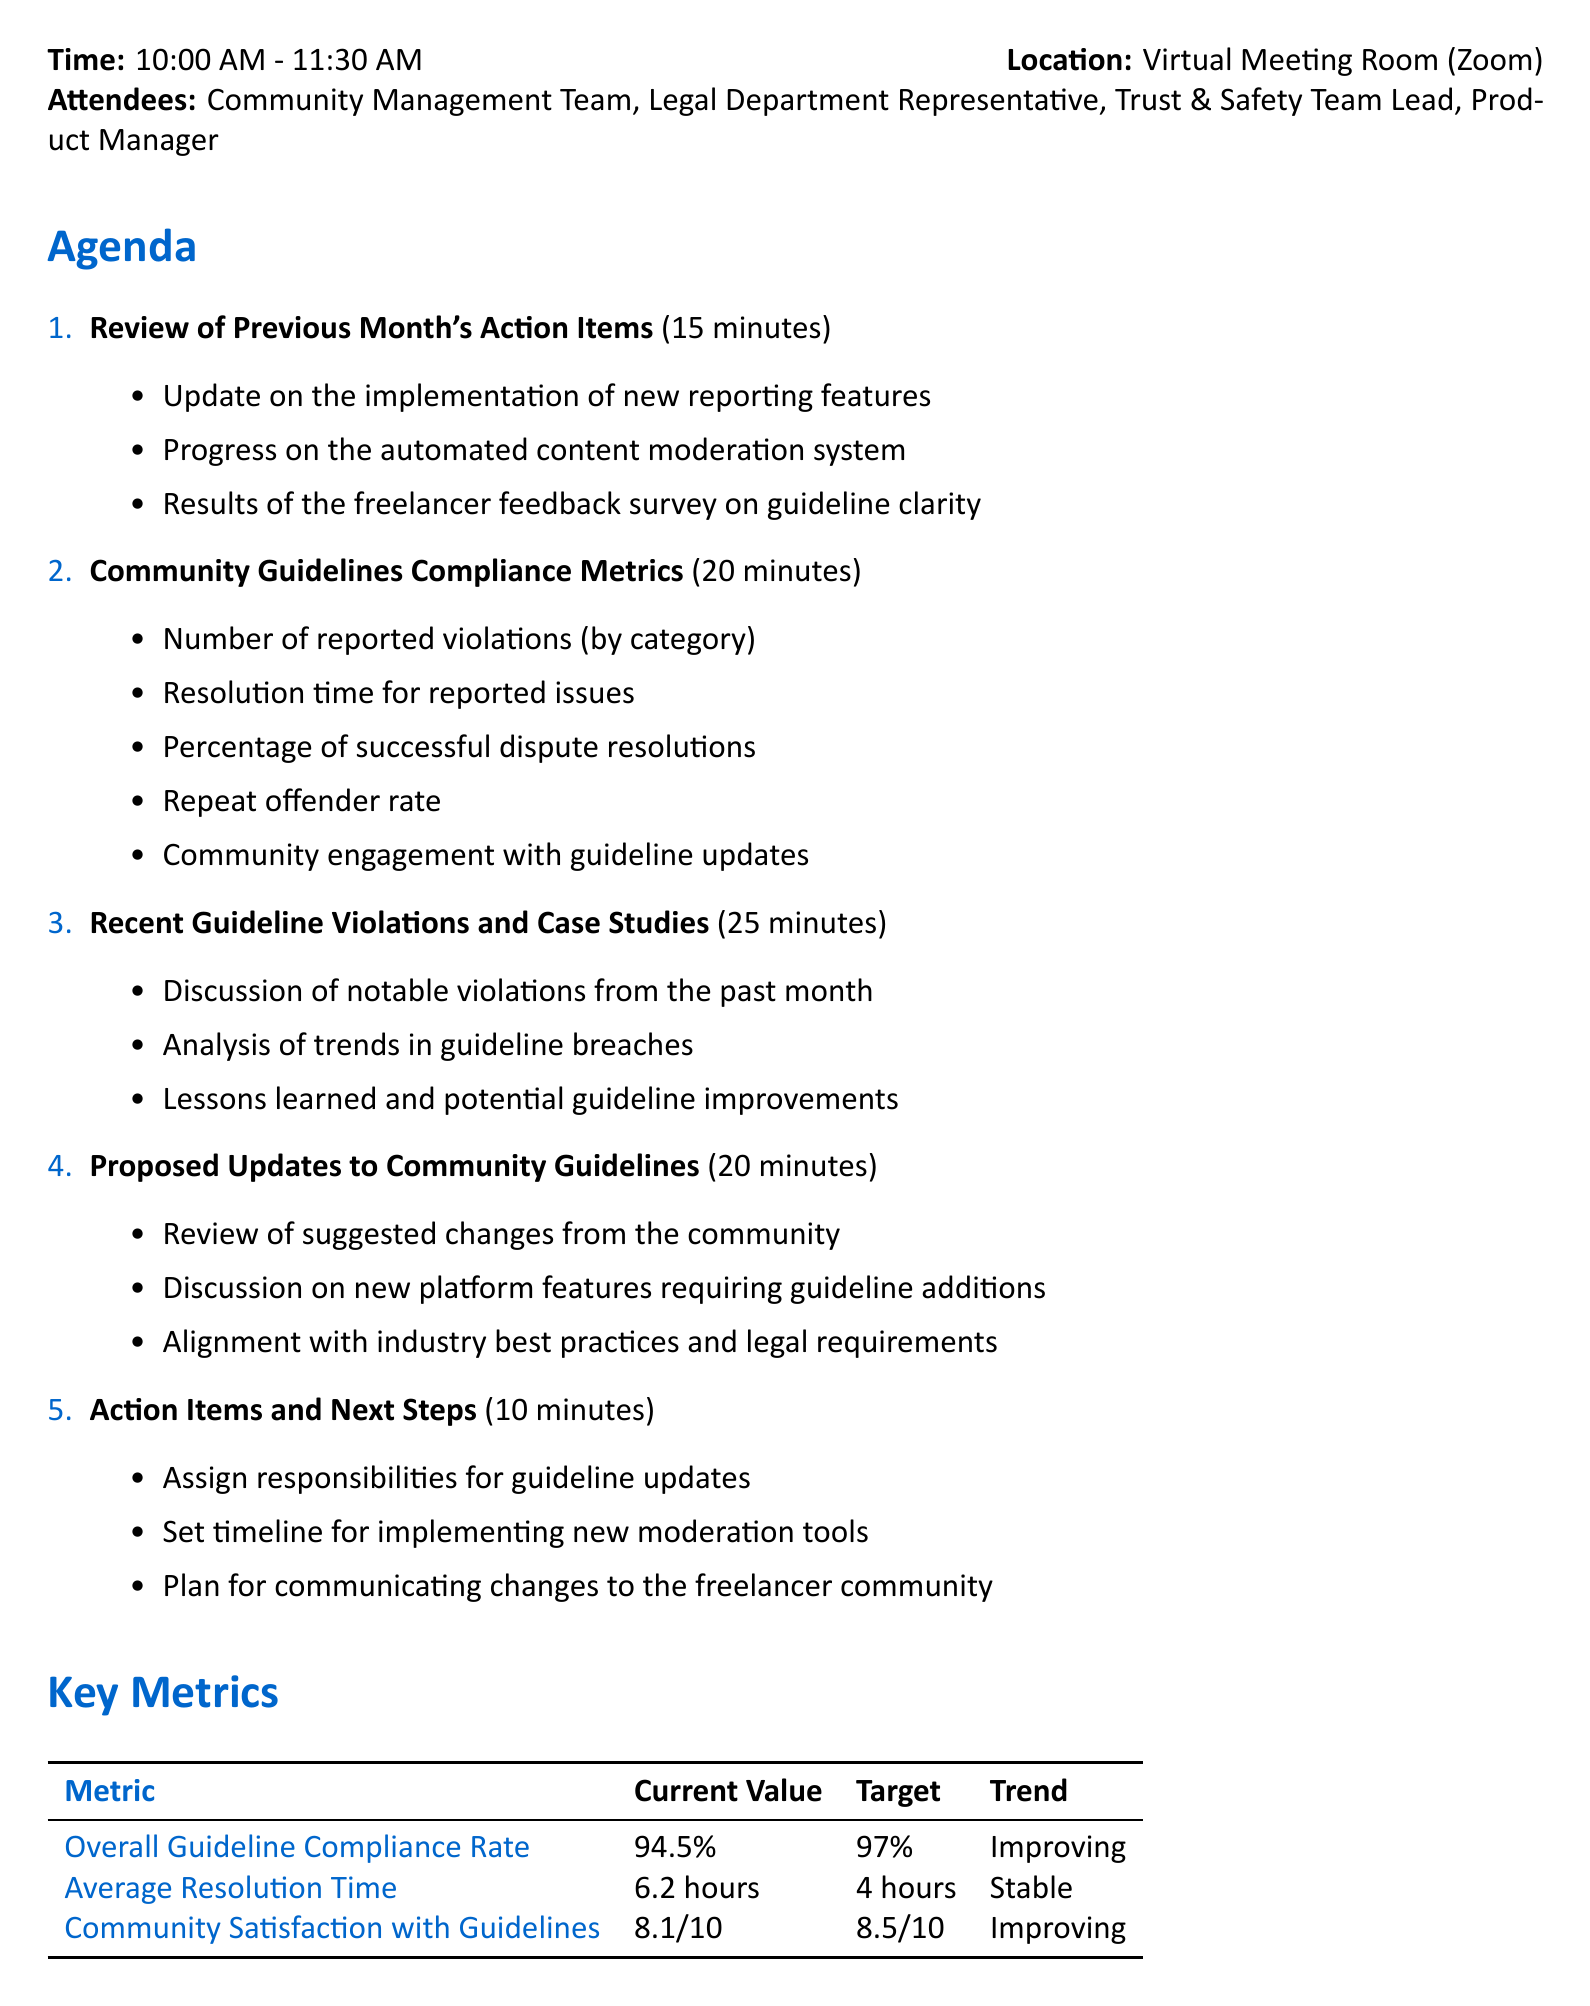What is the date of the meeting? The date of the meeting is explicitly stated at the beginning of the document.
Answer: June 15, 2023 Who is responsible for updating the intellectual property rights section? The owner of the task is identified in the action items section of the document.
Answer: Legal Department What is the average resolution time for reported issues? The average resolution time is provided in the key metrics section of the document.
Answer: 6.2 hours How many minutes are allocated for discussing recent guideline violations? The duration for this agenda item is specified in the agenda section of the document.
Answer: 25 minutes What is the overall guideline compliance rate? This metric is found in the key metrics section of the document.
Answer: 94.5% What are the deadlines for creating guideline infographics? The deadlines for action items are listed in the action items table.
Answer: July 7, 2023 What is the target for community satisfaction with guidelines? The target value is presented alongside the current value in the key metrics section.
Answer: 8.5/10 Which team is tasked with implementing the new AI-powered content filtering system? The owner of this action item is indicated in the action items list.
Answer: Trust & Safety Team 